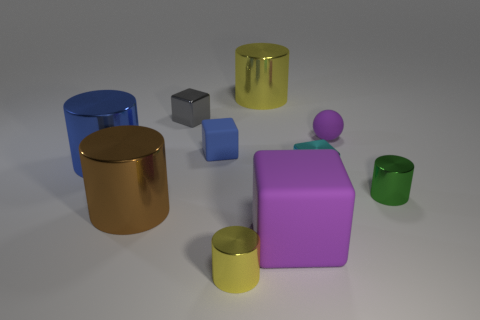Subtract all green blocks. Subtract all brown spheres. How many blocks are left? 4 Subtract all cubes. How many objects are left? 6 Add 3 blue blocks. How many blue blocks exist? 4 Subtract 1 purple spheres. How many objects are left? 9 Subtract all big yellow blocks. Subtract all small metallic cylinders. How many objects are left? 8 Add 1 purple matte cubes. How many purple matte cubes are left? 2 